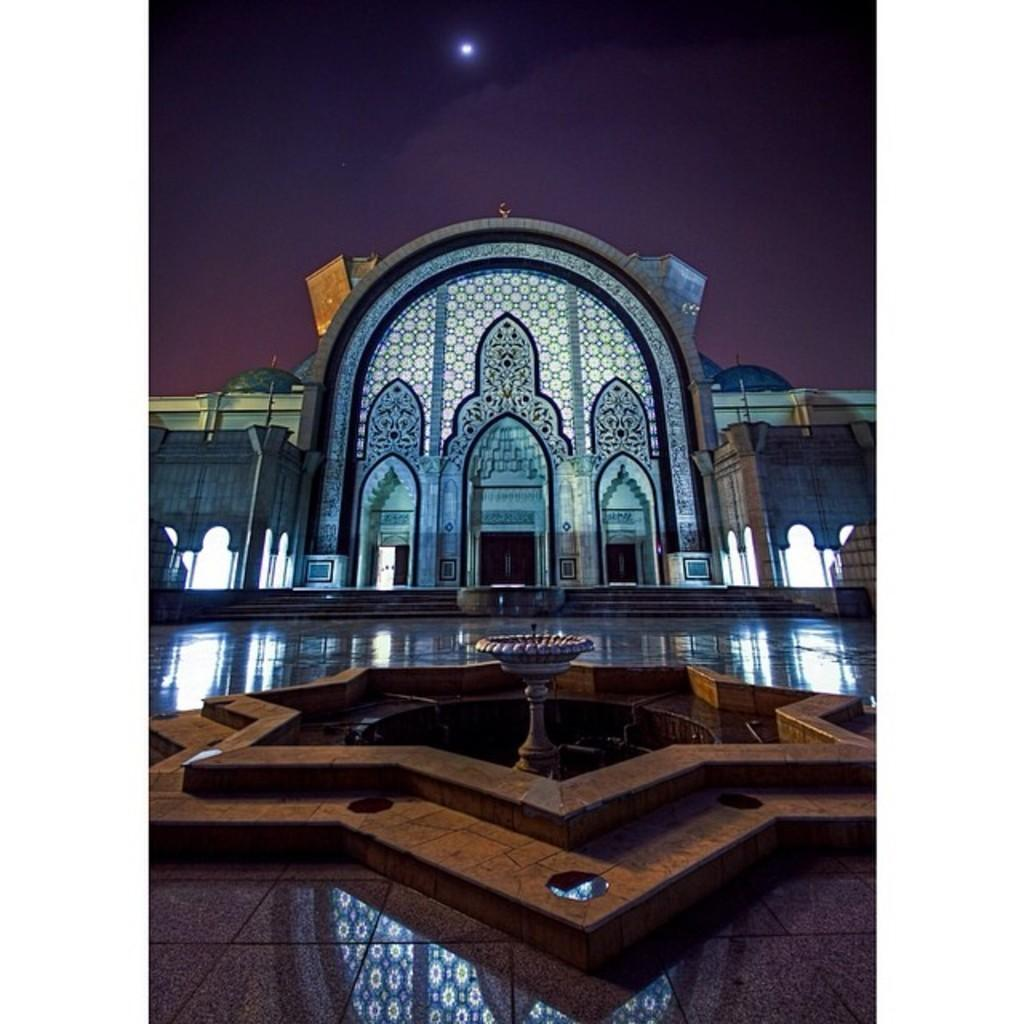What is the main subject in the foreground of the image? There is a fountain in the foreground of the image. What type of surface is the fountain on? The fountain is on a tiled surface. What can be seen in the background of the image? There is a building in the background of the image. How would you describe the sky in the image? The sky is dark in the image. What celestial object is visible in the sky? There is a moon visible in the sky. What type of cough medicine is being sold in the shop in the image? There is no shop present in the image, so it is not possible to determine what type of cough medicine might be sold. 